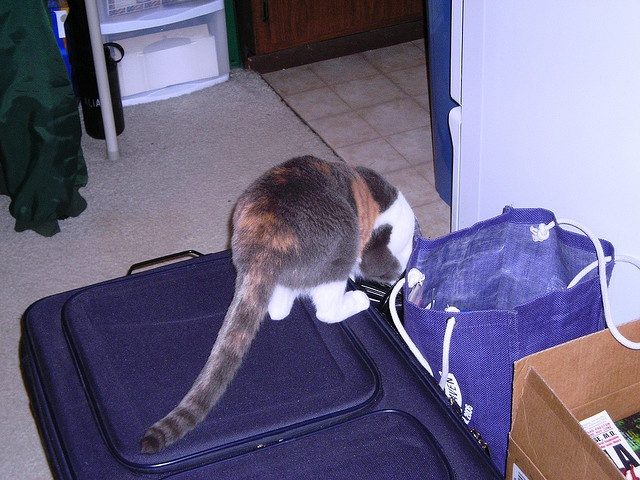Describe the objects in this image and their specific colors. I can see suitcase in black, navy, and purple tones, refrigerator in black, lavender, and blue tones, cat in black, gray, and lavender tones, book in black, lavender, navy, and pink tones, and book in black, gray, olive, and brown tones in this image. 